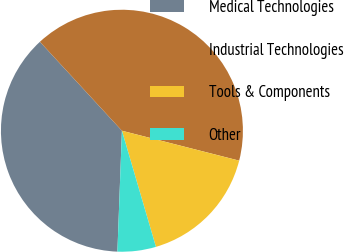<chart> <loc_0><loc_0><loc_500><loc_500><pie_chart><fcel>Medical Technologies<fcel>Industrial Technologies<fcel>Tools & Components<fcel>Other<nl><fcel>37.55%<fcel>40.83%<fcel>16.49%<fcel>5.13%<nl></chart> 